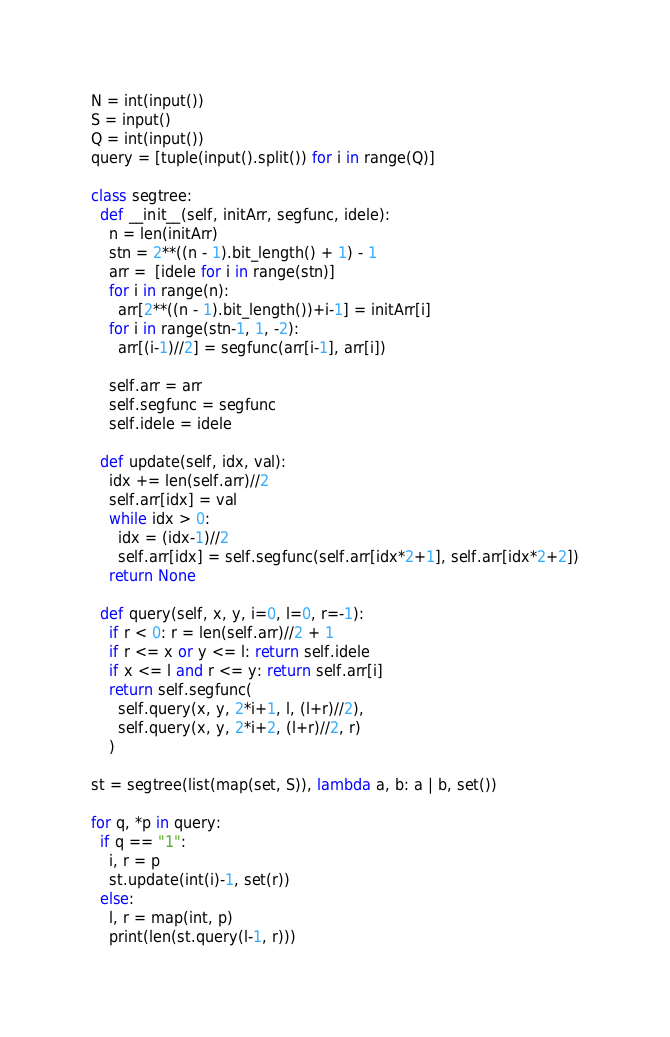<code> <loc_0><loc_0><loc_500><loc_500><_Python_>N = int(input())
S = input()
Q = int(input())
query = [tuple(input().split()) for i in range(Q)]

class segtree:
  def __init__(self, initArr, segfunc, idele):
    n = len(initArr)
    stn = 2**((n - 1).bit_length() + 1) - 1
    arr =  [idele for i in range(stn)]
    for i in range(n):
      arr[2**((n - 1).bit_length())+i-1] = initArr[i]
    for i in range(stn-1, 1, -2):
      arr[(i-1)//2] = segfunc(arr[i-1], arr[i])
  
    self.arr = arr
    self.segfunc = segfunc
    self.idele = idele
  
  def update(self, idx, val):
    idx += len(self.arr)//2
    self.arr[idx] = val
    while idx > 0:
      idx = (idx-1)//2
      self.arr[idx] = self.segfunc(self.arr[idx*2+1], self.arr[idx*2+2])
    return None

  def query(self, x, y, i=0, l=0, r=-1):
    if r < 0: r = len(self.arr)//2 + 1
    if r <= x or y <= l: return self.idele
    if x <= l and r <= y: return self.arr[i]
    return self.segfunc(
      self.query(x, y, 2*i+1, l, (l+r)//2),
      self.query(x, y, 2*i+2, (l+r)//2, r)
    )

st = segtree(list(map(set, S)), lambda a, b: a | b, set())

for q, *p in query:
  if q == "1":
    i, r = p
    st.update(int(i)-1, set(r))
  else:
    l, r = map(int, p)
    print(len(st.query(l-1, r)))</code> 